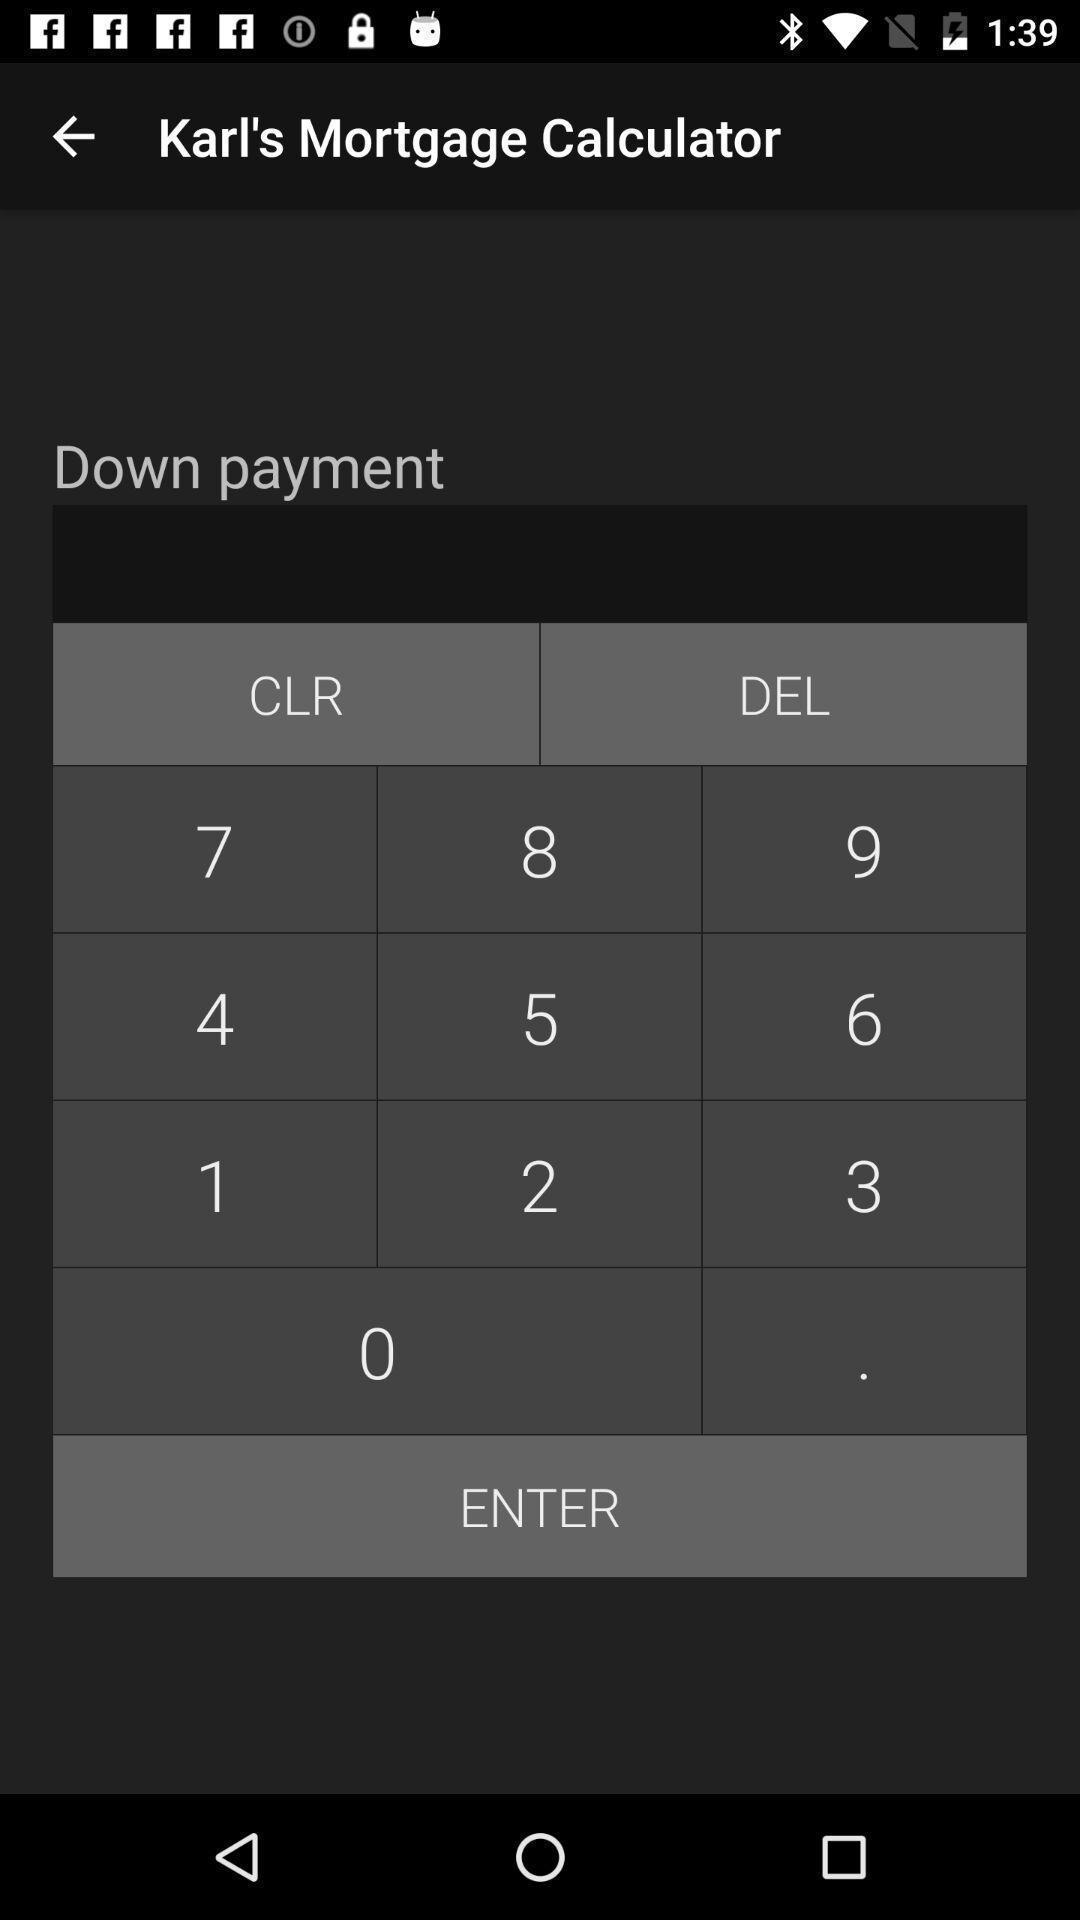Describe this image in words. Screen displaying contents of a calculator. 